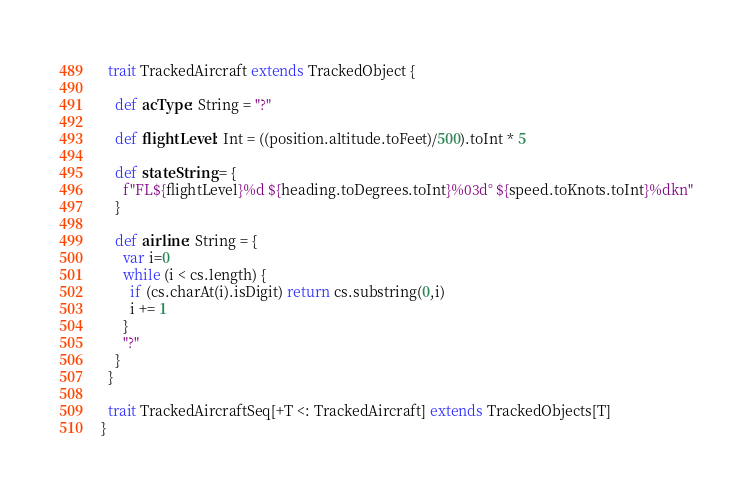Convert code to text. <code><loc_0><loc_0><loc_500><loc_500><_Scala_>  trait TrackedAircraft extends TrackedObject {

    def acType: String = "?"

    def flightLevel: Int = ((position.altitude.toFeet)/500).toInt * 5

    def stateString = {
      f"FL${flightLevel}%d ${heading.toDegrees.toInt}%03d° ${speed.toKnots.toInt}%dkn"
    }

    def airline: String = {
      var i=0
      while (i < cs.length) {
        if (cs.charAt(i).isDigit) return cs.substring(0,i)
        i += 1
      }
      "?"
    }
  }

  trait TrackedAircraftSeq[+T <: TrackedAircraft] extends TrackedObjects[T]
}</code> 